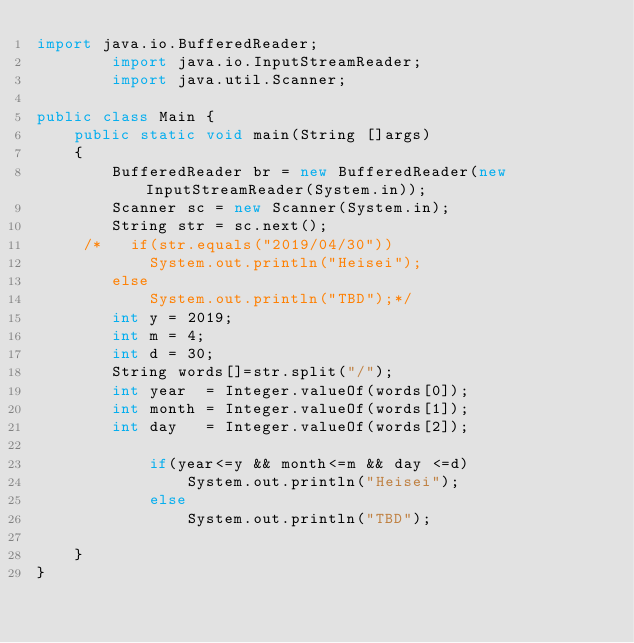<code> <loc_0><loc_0><loc_500><loc_500><_Java_>import java.io.BufferedReader;
        import java.io.InputStreamReader;
        import java.util.Scanner;

public class Main {
    public static void main(String []args)
    {
        BufferedReader br = new BufferedReader(new InputStreamReader(System.in));
        Scanner sc = new Scanner(System.in);
        String str = sc.next();
     /*   if(str.equals("2019/04/30"))
            System.out.println("Heisei");
        else
            System.out.println("TBD");*/
        int y = 2019;
        int m = 4;
        int d = 30;
        String words[]=str.split("/");
        int year  = Integer.valueOf(words[0]);
        int month = Integer.valueOf(words[1]);
        int day   = Integer.valueOf(words[2]);

            if(year<=y && month<=m && day <=d)
                System.out.println("Heisei");
            else
                System.out.println("TBD");

    }
}
</code> 